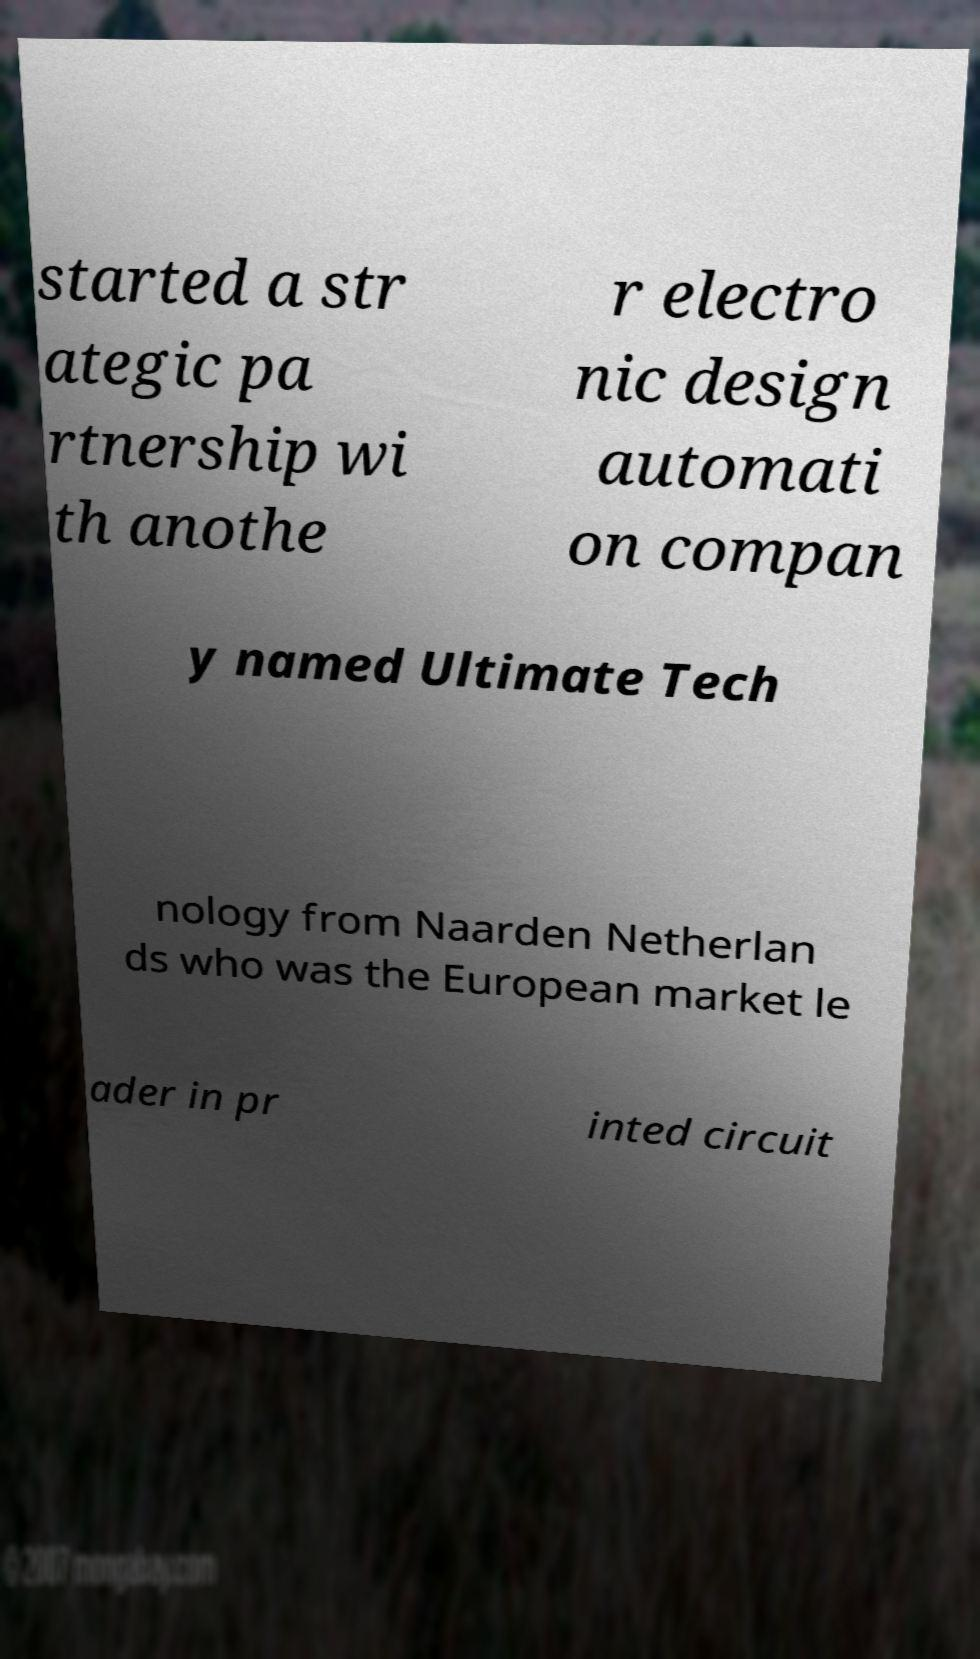Could you extract and type out the text from this image? started a str ategic pa rtnership wi th anothe r electro nic design automati on compan y named Ultimate Tech nology from Naarden Netherlan ds who was the European market le ader in pr inted circuit 